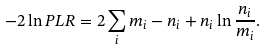<formula> <loc_0><loc_0><loc_500><loc_500>- 2 \ln P L R = 2 \sum _ { i } m _ { i } - n _ { i } + n _ { i } \ln \frac { n _ { i } } { m _ { i } } .</formula> 